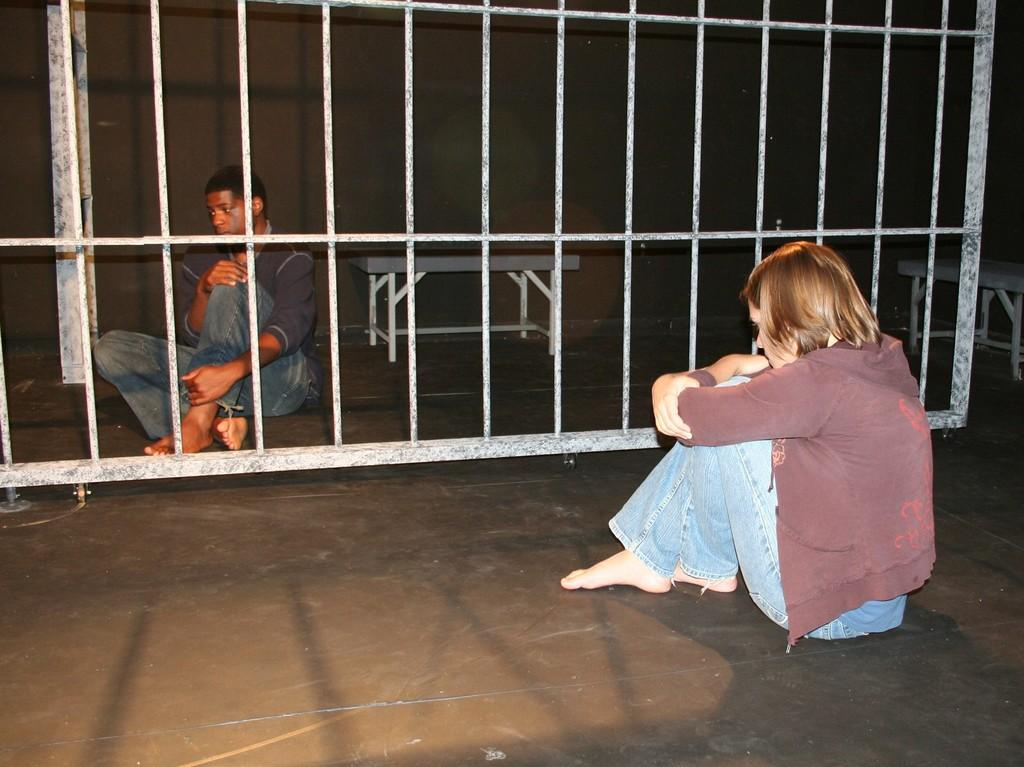Who is present in the image? There is a man and a woman in the image. What are they doing in the image? They are sitting on the floor. What object with wheels can be seen in the image? There is a gate with wheels in the image. What type of seating is available in the image? There are benches in the image. What can be seen on the wall in the image? The wall is black in color. What type of needle is being used by the man in the image? There is no needle present in the image. What type of coach is visible in the image? There is no coach present in the image. 